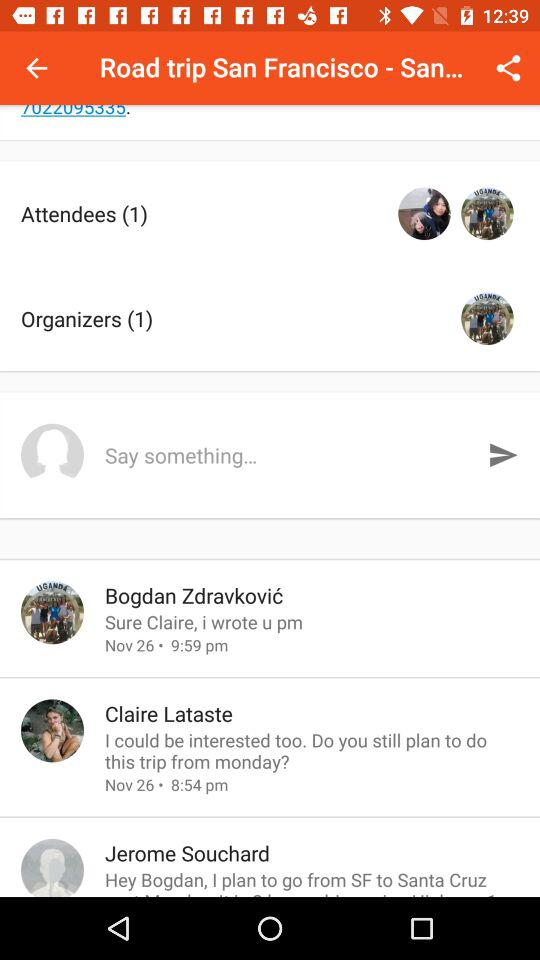How many messages are there in this chat?
Answer the question using a single word or phrase. 3 